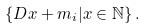Convert formula to latex. <formula><loc_0><loc_0><loc_500><loc_500>\left \{ D x + m _ { i } | x \in \mathbb { N } \right \} .</formula> 